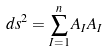Convert formula to latex. <formula><loc_0><loc_0><loc_500><loc_500>d s ^ { 2 } = \sum _ { I = 1 } ^ { n } A _ { I } A _ { I }</formula> 